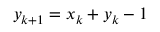<formula> <loc_0><loc_0><loc_500><loc_500>y _ { k + 1 } = x _ { k } + y _ { k } - 1</formula> 